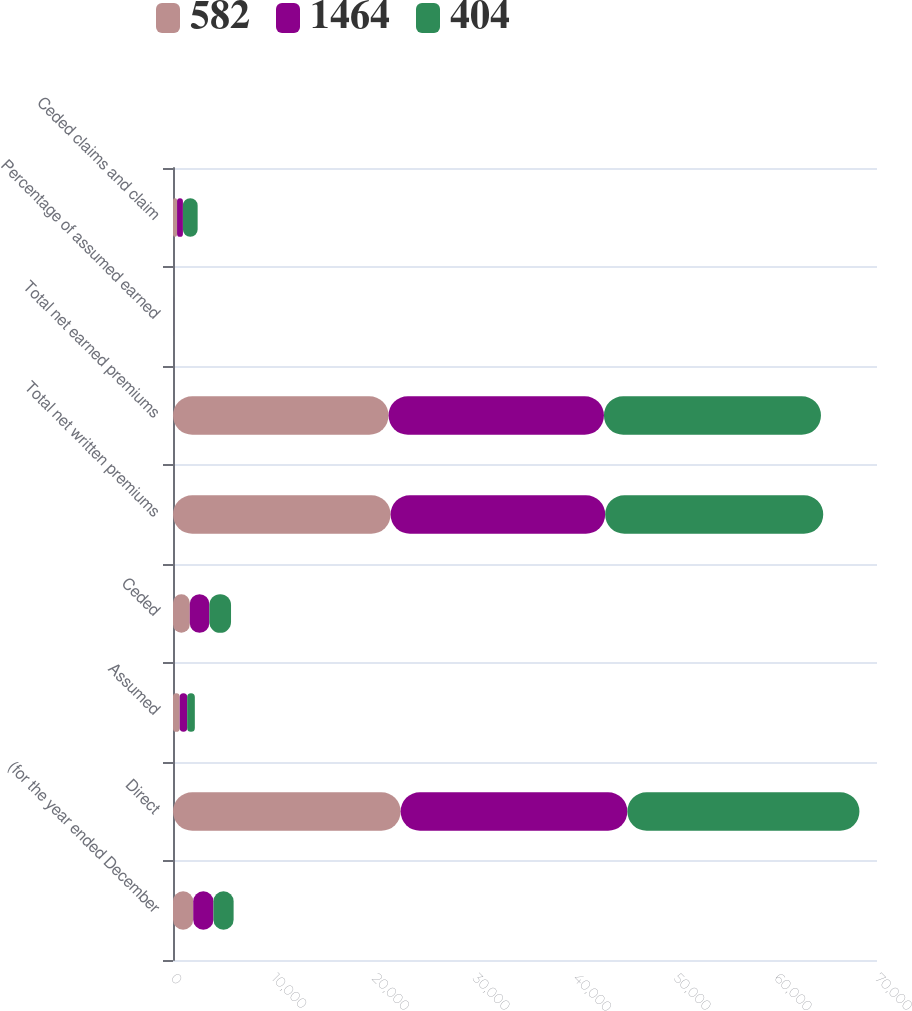<chart> <loc_0><loc_0><loc_500><loc_500><stacked_bar_chart><ecel><fcel>(for the year ended December<fcel>Direct<fcel>Assumed<fcel>Ceded<fcel>Total net written premiums<fcel>Total net earned premiums<fcel>Percentage of assumed earned<fcel>Ceded claims and claim<nl><fcel>582<fcel>2010<fcel>22634<fcel>668<fcel>1667<fcel>21635<fcel>21432<fcel>3.1<fcel>404<nl><fcel>1464<fcel>2009<fcel>22545<fcel>740<fcel>1949<fcel>21336<fcel>21418<fcel>3.6<fcel>582<nl><fcel>404<fcel>2008<fcel>23074<fcel>763<fcel>2154<fcel>21683<fcel>21579<fcel>3.6<fcel>1464<nl></chart> 